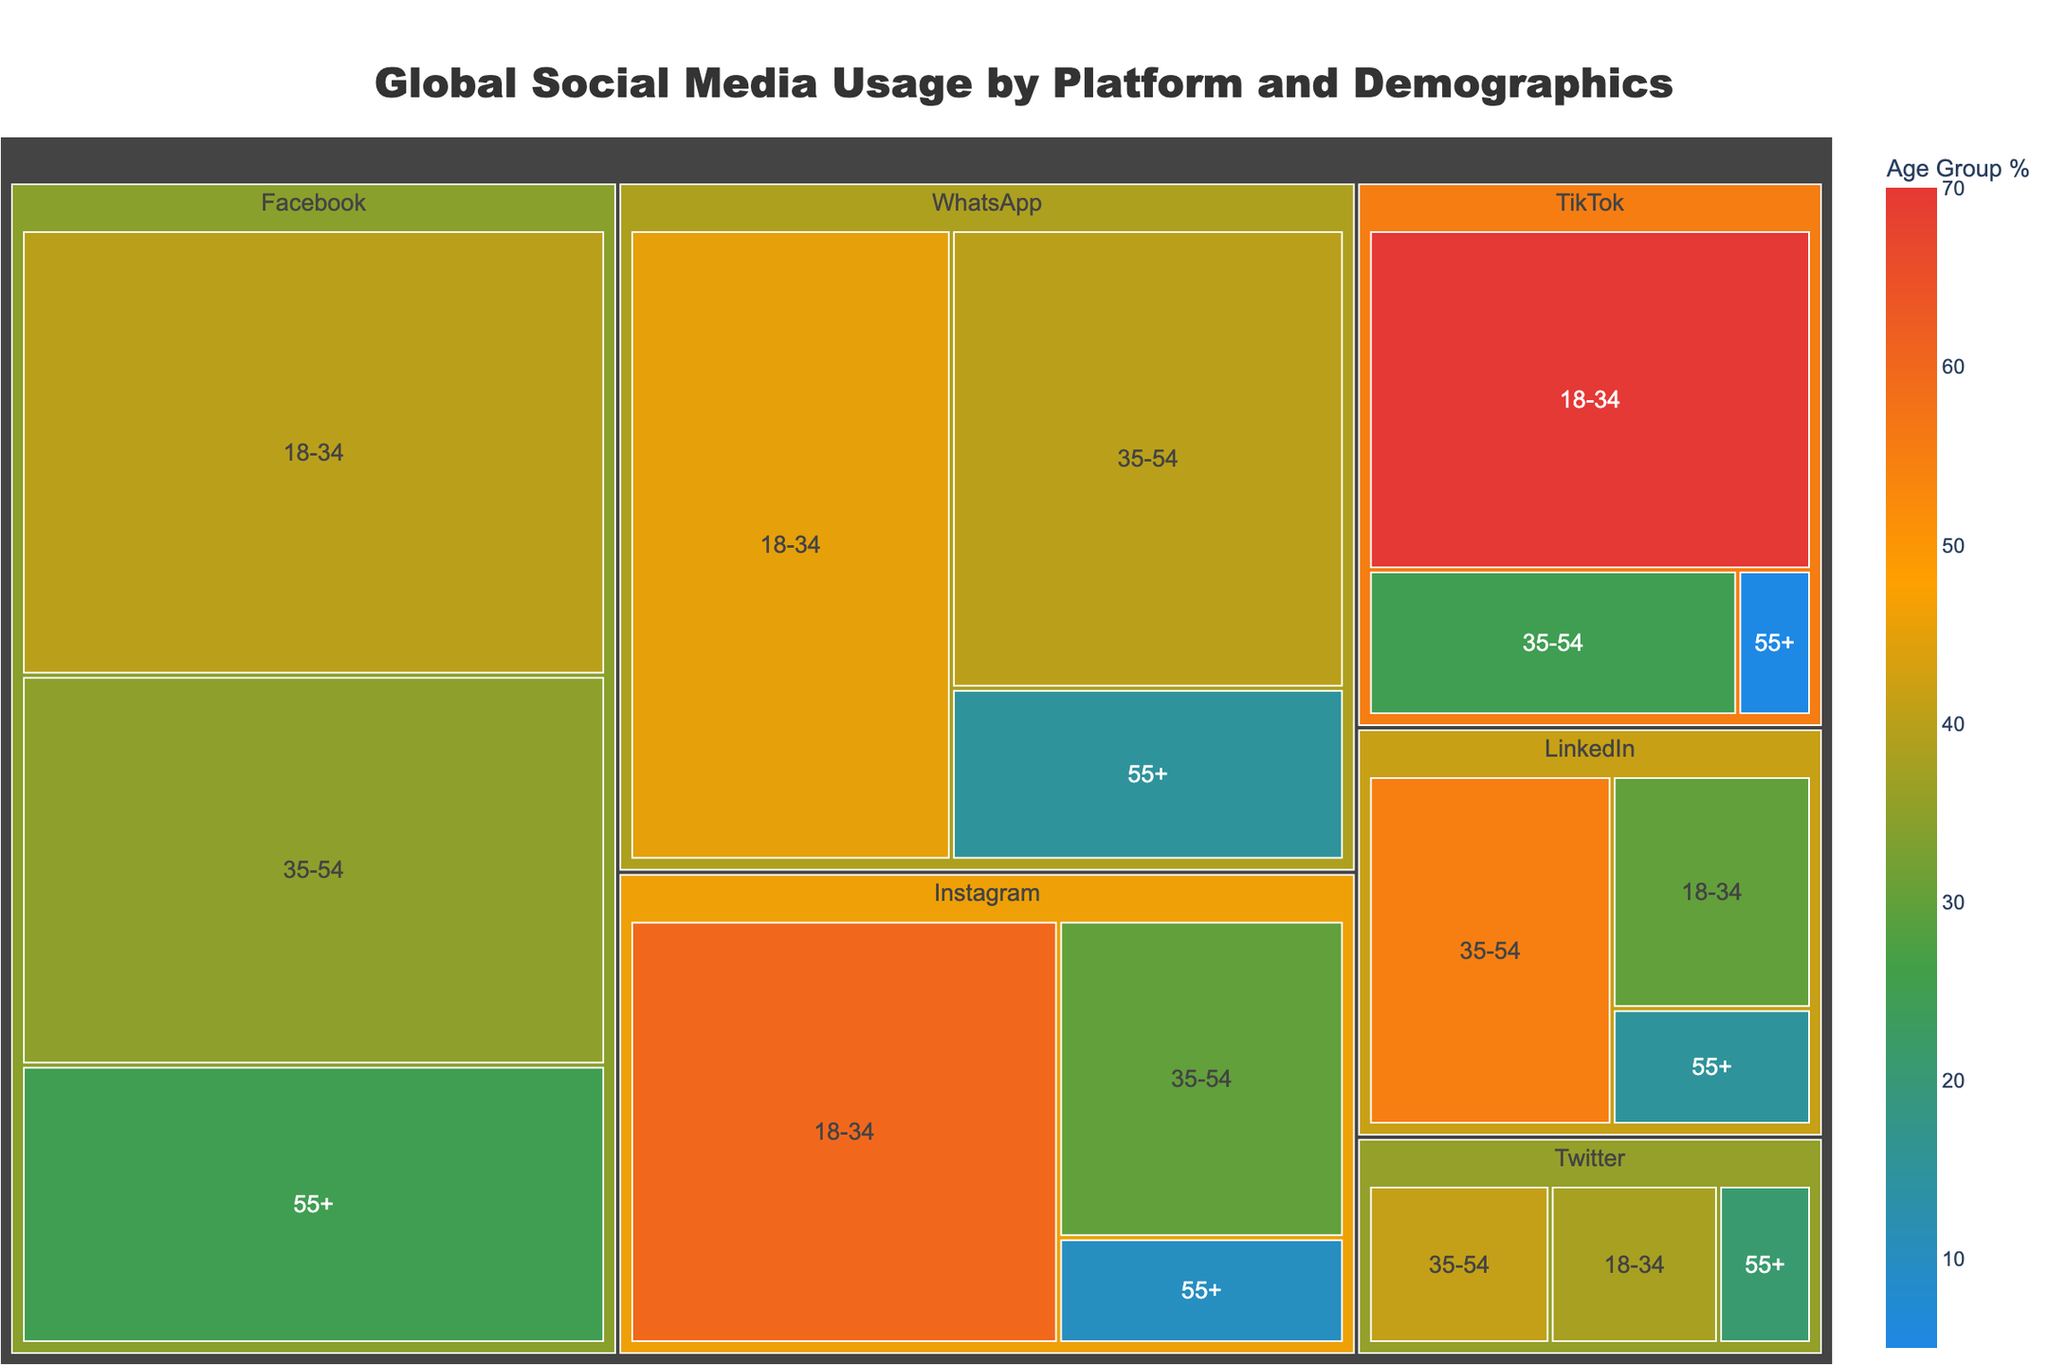what is the total number of active users on Facebook? To find the total number of active users on Facebook, look at the section labeled "Facebook." The figure might include these details in the hover information or data label.
Answer: 2,800,000,000 Which platform has the highest percentage of users aged 18-34? By comparing the percentages of 18-34 age groups across all platforms, TikTok has the highest percentage.
Answer: TikTok What is the combined percentage of WhatsApp users in the 18-34 and 55+ age groups? For WhatsApp, users aged 18-34 make up 45% and users aged 55+ make up 15%. Summing these percentages yields 60%.
Answer: 60% Among all platforms, which one has the lowest percentage of users aged 35-54? Comparing the percentage values for the 35-54 age group across platforms, TikTok has the lowest percentage at 25%.
Answer: TikTok Which platform has the largest number of active users in the 35-54 age group? To determine this, compare the number of users in the 35-54 age group for each platform. Despite differing percentages, Facebook holds the largest number due to its high total user base.
Answer: Facebook How does the number of active users aged 18-34 on LinkedIn compare to those of Twitter in the same age group? LinkedIn has 750,000,000 users with 30% aged 18-34, resulting in 225,000,000 for that group. Twitter has 400,000,000 users with 38% aged 18-34, resulting in 152,000,000. Thus, LinkedIn has more users in this age group.
Answer: LinkedIn What proportion of TikTok's users are either 18-34 or 35-54? TikTok's 18-34 age group constitutes 70%, and the 35-54 age group constitutes 25%. Adding these gives 95%.
Answer: 95% Is the percentage of Instagram users aged 55+ greater or less than that of Twitter users in the same age group? The percentage of Instagram users aged 55+ is 10%, while Twitter has 21% in this age group. Therefore, Instagram has a lower percentage.
Answer: less Considering all platforms, which one has the smallest age group percentage value present in the figure? The smallest age group percentage across all platforms in this dataset is for TikTok's 55+ category at 5%.
Answer: TikTok What is the average percentage of users in the 35-54 age group across all platforms? To find the average percentage for the 35-54 age group, sum all percentages (35 + 30 + 40 + 41 + 55 + 25) and divide by the number of platforms (6), resulting in 226 / 6 = 37.67%.
Answer: 37.67% 